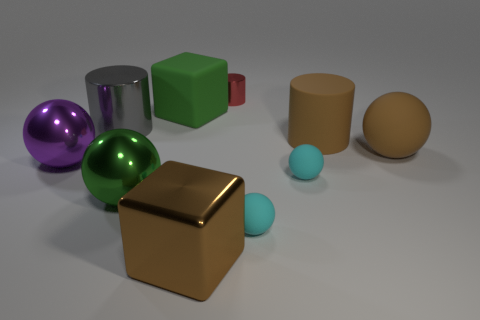Subtract 1 cylinders. How many cylinders are left? 2 Subtract all big purple balls. How many balls are left? 4 Subtract all cylinders. How many objects are left? 7 Subtract all green spheres. How many spheres are left? 4 Subtract 0 blue blocks. How many objects are left? 10 Subtract all brown cylinders. Subtract all blue cubes. How many cylinders are left? 2 Subtract all green spheres. How many red cubes are left? 0 Subtract all brown cubes. Subtract all big purple rubber balls. How many objects are left? 9 Add 2 matte balls. How many matte balls are left? 5 Add 9 brown blocks. How many brown blocks exist? 10 